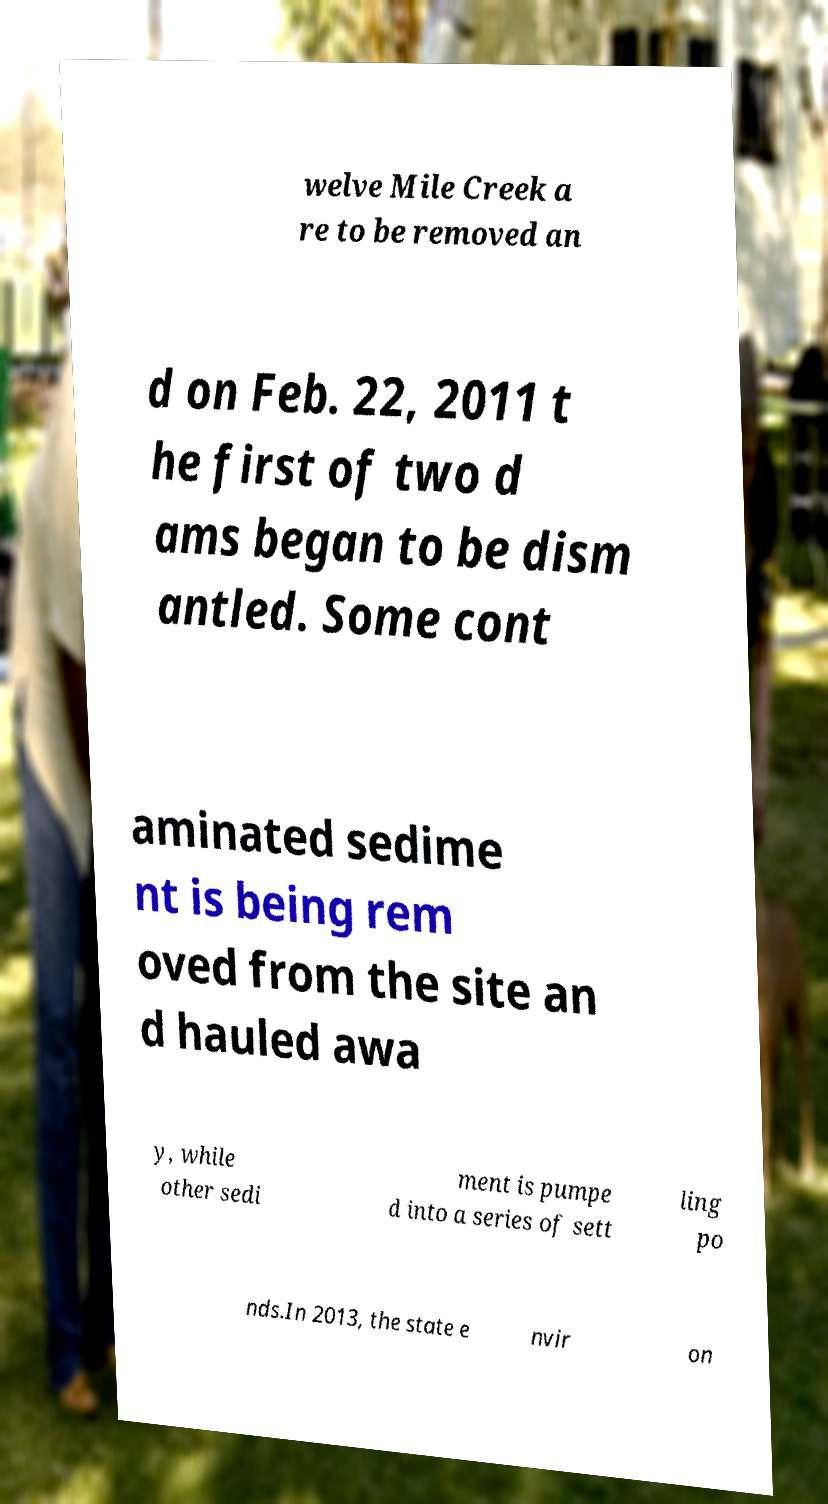Please read and relay the text visible in this image. What does it say? welve Mile Creek a re to be removed an d on Feb. 22, 2011 t he first of two d ams began to be dism antled. Some cont aminated sedime nt is being rem oved from the site an d hauled awa y, while other sedi ment is pumpe d into a series of sett ling po nds.In 2013, the state e nvir on 